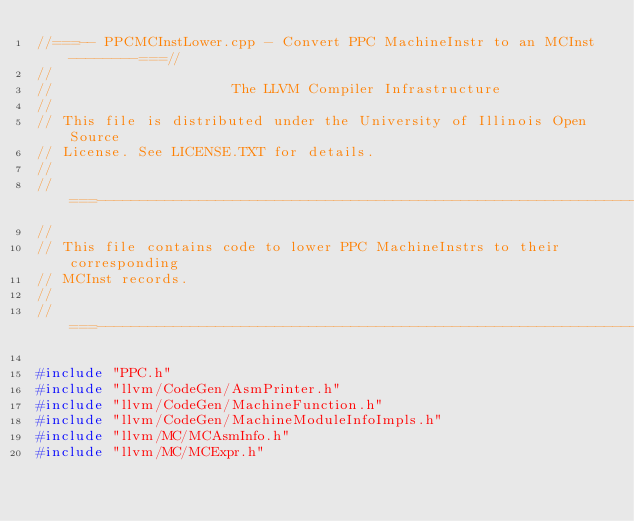<code> <loc_0><loc_0><loc_500><loc_500><_C++_>//===-- PPCMCInstLower.cpp - Convert PPC MachineInstr to an MCInst --------===//
//
//                     The LLVM Compiler Infrastructure
//
// This file is distributed under the University of Illinois Open Source
// License. See LICENSE.TXT for details.
//
//===----------------------------------------------------------------------===//
//
// This file contains code to lower PPC MachineInstrs to their corresponding
// MCInst records.
//
//===----------------------------------------------------------------------===//

#include "PPC.h"
#include "llvm/CodeGen/AsmPrinter.h"
#include "llvm/CodeGen/MachineFunction.h"
#include "llvm/CodeGen/MachineModuleInfoImpls.h"
#include "llvm/MC/MCAsmInfo.h"
#include "llvm/MC/MCExpr.h"</code> 